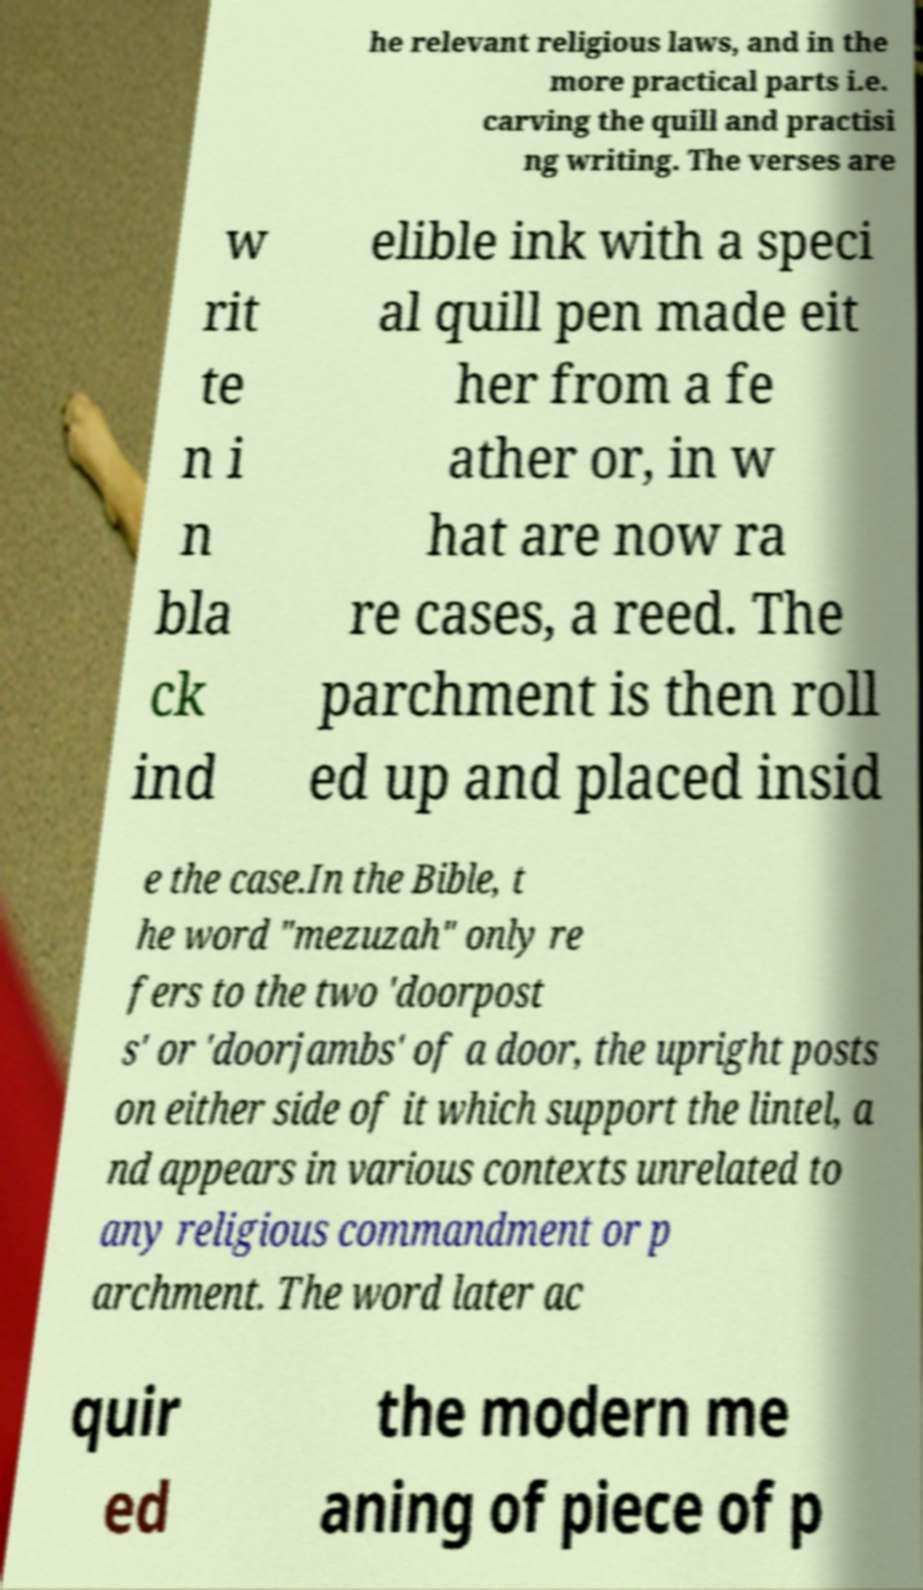Could you extract and type out the text from this image? he relevant religious laws, and in the more practical parts i.e. carving the quill and practisi ng writing. The verses are w rit te n i n bla ck ind elible ink with a speci al quill pen made eit her from a fe ather or, in w hat are now ra re cases, a reed. The parchment is then roll ed up and placed insid e the case.In the Bible, t he word "mezuzah" only re fers to the two 'doorpost s' or 'doorjambs' of a door, the upright posts on either side of it which support the lintel, a nd appears in various contexts unrelated to any religious commandment or p archment. The word later ac quir ed the modern me aning of piece of p 